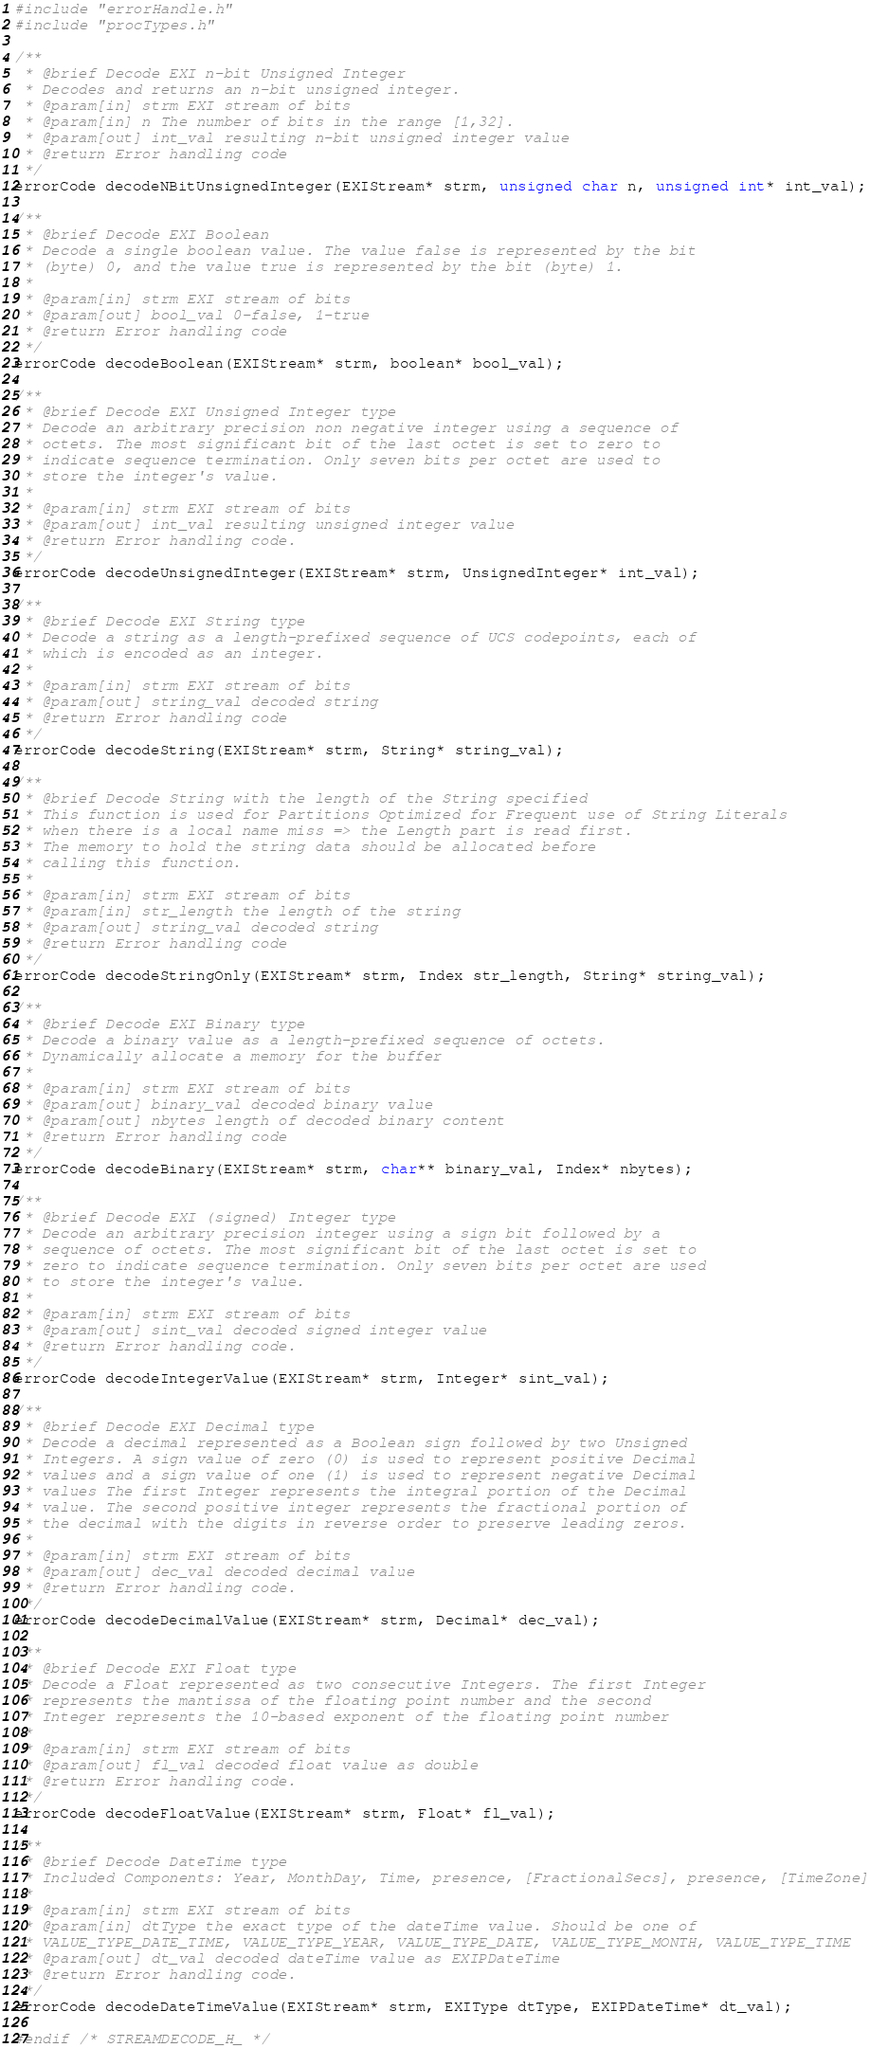Convert code to text. <code><loc_0><loc_0><loc_500><loc_500><_C_>
#include "errorHandle.h"
#include "procTypes.h"

/**
 * @brief Decode EXI n-bit Unsigned Integer
 * Decodes and returns an n-bit unsigned integer.
 * @param[in] strm EXI stream of bits
 * @param[in] n The number of bits in the range [1,32].
 * @param[out] int_val resulting n-bit unsigned integer value
 * @return Error handling code
 */
errorCode decodeNBitUnsignedInteger(EXIStream* strm, unsigned char n, unsigned int* int_val);

/**
 * @brief Decode EXI Boolean
 * Decode a single boolean value. The value false is represented by the bit
 * (byte) 0, and the value true is represented by the bit (byte) 1.
 *
 * @param[in] strm EXI stream of bits
 * @param[out] bool_val 0-false, 1-true
 * @return Error handling code
 */
errorCode decodeBoolean(EXIStream* strm, boolean* bool_val);

/**
 * @brief Decode EXI Unsigned Integer type
 * Decode an arbitrary precision non negative integer using a sequence of
 * octets. The most significant bit of the last octet is set to zero to
 * indicate sequence termination. Only seven bits per octet are used to
 * store the integer's value.
 *
 * @param[in] strm EXI stream of bits
 * @param[out] int_val resulting unsigned integer value
 * @return Error handling code.
 */
errorCode decodeUnsignedInteger(EXIStream* strm, UnsignedInteger* int_val);

/**
 * @brief Decode EXI String type
 * Decode a string as a length-prefixed sequence of UCS codepoints, each of
 * which is encoded as an integer.
 *
 * @param[in] strm EXI stream of bits
 * @param[out] string_val decoded string
 * @return Error handling code
 */
errorCode decodeString(EXIStream* strm, String* string_val);

/**
 * @brief Decode String with the length of the String specified
 * This function is used for Partitions Optimized for Frequent use of String Literals
 * when there is a local name miss => the Length part is read first.
 * The memory to hold the string data should be allocated before
 * calling this function.
 *
 * @param[in] strm EXI stream of bits
 * @param[in] str_length the length of the string
 * @param[out] string_val decoded string
 * @return Error handling code
 */
errorCode decodeStringOnly(EXIStream* strm, Index str_length, String* string_val);

/**
 * @brief Decode EXI Binary type
 * Decode a binary value as a length-prefixed sequence of octets.
 * Dynamically allocate a memory for the buffer
 *
 * @param[in] strm EXI stream of bits
 * @param[out] binary_val decoded binary value
 * @param[out] nbytes length of decoded binary content
 * @return Error handling code
 */
errorCode decodeBinary(EXIStream* strm, char** binary_val, Index* nbytes);

/**
 * @brief Decode EXI (signed) Integer type
 * Decode an arbitrary precision integer using a sign bit followed by a
 * sequence of octets. The most significant bit of the last octet is set to
 * zero to indicate sequence termination. Only seven bits per octet are used
 * to store the integer's value.
 *
 * @param[in] strm EXI stream of bits
 * @param[out] sint_val decoded signed integer value
 * @return Error handling code.
 */
errorCode decodeIntegerValue(EXIStream* strm, Integer* sint_val);

/**
 * @brief Decode EXI Decimal type
 * Decode a decimal represented as a Boolean sign followed by two Unsigned
 * Integers. A sign value of zero (0) is used to represent positive Decimal
 * values and a sign value of one (1) is used to represent negative Decimal
 * values The first Integer represents the integral portion of the Decimal
 * value. The second positive integer represents the fractional portion of
 * the decimal with the digits in reverse order to preserve leading zeros.
 *
 * @param[in] strm EXI stream of bits
 * @param[out] dec_val decoded decimal value
 * @return Error handling code.
 */
errorCode decodeDecimalValue(EXIStream* strm, Decimal* dec_val);

/**
 * @brief Decode EXI Float type
 * Decode a Float represented as two consecutive Integers. The first Integer
 * represents the mantissa of the floating point number and the second
 * Integer represents the 10-based exponent of the floating point number
 *
 * @param[in] strm EXI stream of bits
 * @param[out] fl_val decoded float value as double
 * @return Error handling code.
 */
errorCode decodeFloatValue(EXIStream* strm, Float* fl_val);

/**
 * @brief Decode DateTime type
 * Included Components: Year, MonthDay, Time, presence, [FractionalSecs], presence, [TimeZone]
 *
 * @param[in] strm EXI stream of bits
 * @param[in] dtType the exact type of the dateTime value. Should be one of
 * VALUE_TYPE_DATE_TIME, VALUE_TYPE_YEAR, VALUE_TYPE_DATE, VALUE_TYPE_MONTH, VALUE_TYPE_TIME
 * @param[out] dt_val decoded dateTime value as EXIPDateTime
 * @return Error handling code.
 */
errorCode decodeDateTimeValue(EXIStream* strm, EXIType dtType, EXIPDateTime* dt_val);

#endif /* STREAMDECODE_H_ */
</code> 